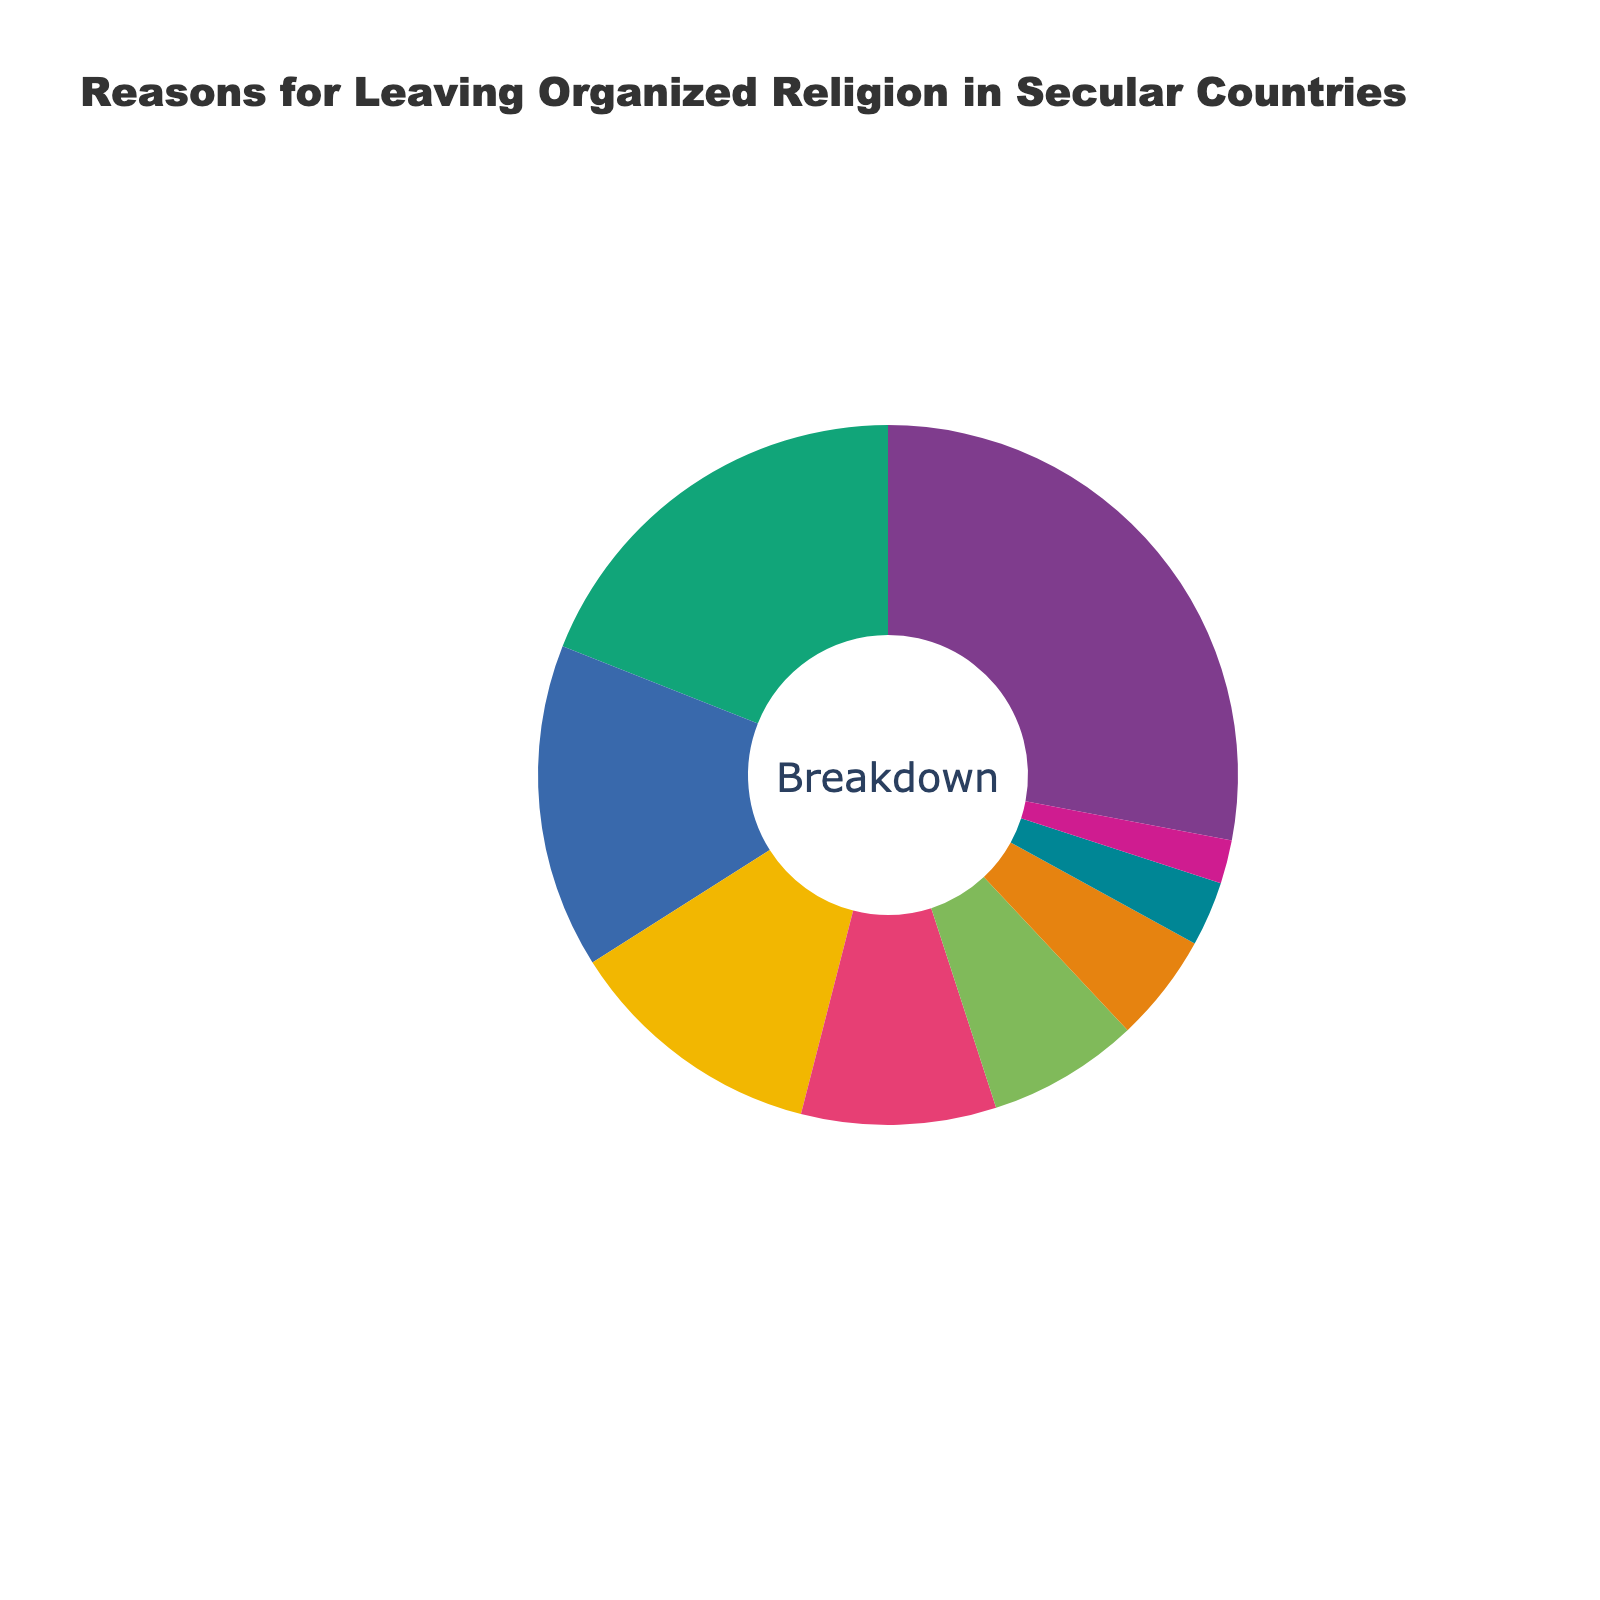What is the most common reason given for leaving organized religion in secular countries? The figure shows a breakdown of reasons with percentages for each reason. The most common reason will have the largest percentage. "Loss of faith in religious teachings" has the highest percentage at 28%.
Answer: Loss of faith in religious teachings How many reasons together account for more than 50% of the cases? To answer this, identify the largest percentages and sum them until the total exceeds 50%. The top three reasons are 28%, 19%, and 15%, which sum to 62%.
Answer: 3 What is the percentage difference between "Scientific explanations for natural phenomena" and "Exposure to diverse worldviews"? "Scientific explanations for natural phenomena" has 19% and "Exposure to diverse worldviews" has 12%. Subtract the smaller percentage from the larger. 19% - 12% = 7%.
Answer: 7% Which reason has the smallest representation, and what is its percentage? Identify the reason with the smallest slice of the pie chart, which is represented by the smallest percentage. "Rejection of religious authority" has the smallest percentage at 2%.
Answer: Rejection of religious authority, 2% What is the sum of the percentages for "Perceived hypocrisy in religious institutions" and "Personal experiences contradicting religious claims"? Add the percentages for "Perceived hypocrisy in religious institutions" (9%) and "Personal experiences contradicting religious claims" (7%). 9% + 7% = 16%.
Answer: 16% How many reasons account for less than 10% each? Count the reasons with percentages less than 10%. The reasons are "Perceived hypocrisy in religious institutions" (9%), "Personal experiences contradicting religious claims" (7%), "Desire for intellectual freedom" (5%), "Influence of secular education" (3%), and "Rejection of religious authority" (2%), totaling five reasons.
Answer: 5 Which two reasons combined equal the percentage of "Loss of faith in religious teachings"? Find two reasons whose percentages add up to 28%. "Scientific explanations for natural phenomena" (19%) and "Desire for intellectual freedom" (5%) sum to 24% and "Disagreement with religious stance on social issues" (15%) and "Exposure to diverse worldviews" (12%) sum to 27%, but none exactly add up to 28%. Therefore, no two reasons combined exactly equal 28%.
Answer: None What is the percentage difference between "Disagreement with religious stance on social issues" and "Perceived hypocrisy in religious institutions"? "Disagreement with religious stance on social issues" has 15% and "Perceived hypocrisy in religious institutions" has 9%. Subtract the smaller percentage from the larger. 15% - 9% = 6%.
Answer: 6% 